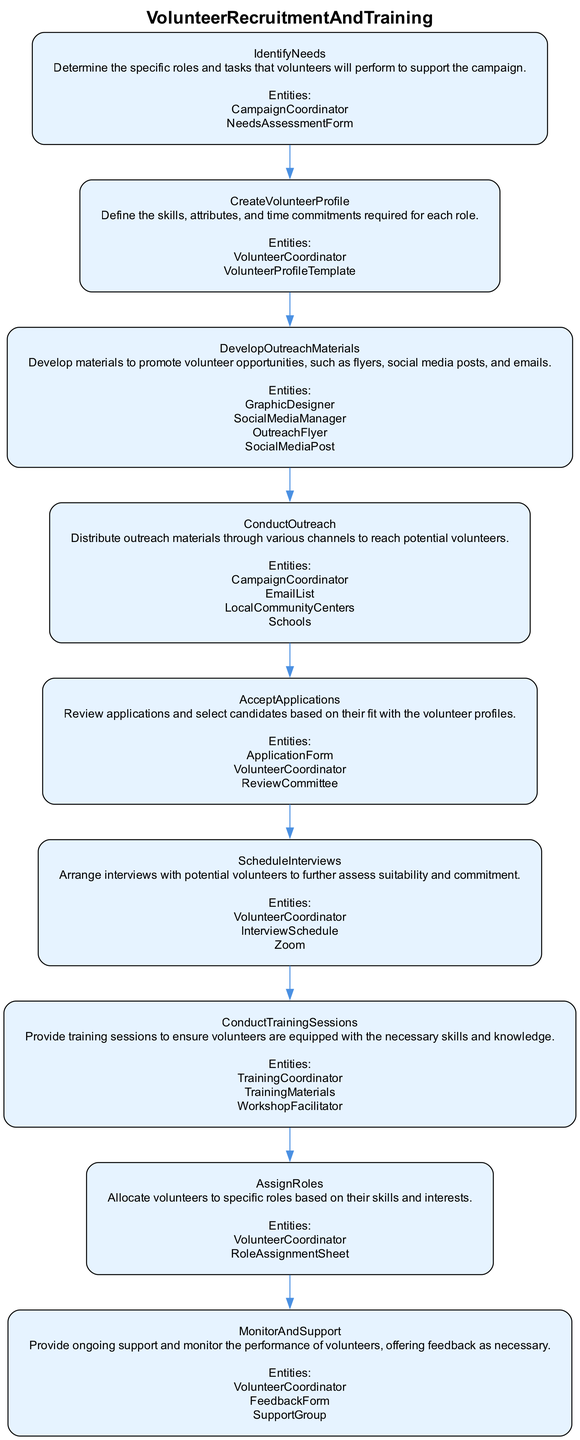What is the first step in the process? The first step in the diagram is labeled "IdentifyNeeds," which outlines the process of determining the specific roles and tasks for volunteers.
Answer: IdentifyNeeds How many total steps are there? By counting the steps listed in the diagram, there are a total of 9 steps from identification to monitoring.
Answer: 9 What entity is involved in creating the volunteer profile? The entity responsible for creating the volunteer profile is the "VolunteerCoordinator," who uses a "VolunteerProfileTemplate" to define the skills required.
Answer: VolunteerCoordinator Which step comes after conducting outreach? After conducting outreach, the next step is "AcceptApplications," which involves reviewing applications for volunteer candidates.
Answer: AcceptApplications What is the purpose of the "ConductTrainingSessions"? The purpose of "ConductTrainingSessions" is to provide training to ensure that volunteers have the necessary skills and knowledge to perform their roles effectively.
Answer: Provide training What is the last step in the volunteer recruitment process? The last step in the recruitment process is "MonitorAndSupport," which focuses on providing ongoing support and feedback to volunteers.
Answer: MonitorAndSupport Which entities are involved in the final step? The entities involved in the final step "MonitorAndSupport" are "VolunteerCoordinator," "FeedbackForm," and "SupportGroup," which assist in the support and monitoring process.
Answer: VolunteerCoordinator, FeedbackForm, SupportGroup How can the roles be assigned to volunteers? Roles are assigned to volunteers in the "AssignRoles" step based on the skills and interests defined in previous stages of recruitment.
Answer: Based on skills and interests What is required before scheduling interviews? Before scheduling interviews, it is necessary to complete the "AcceptApplications" step, where applications are reviewed to select suitable candidates.
Answer: Complete AcceptApplications 